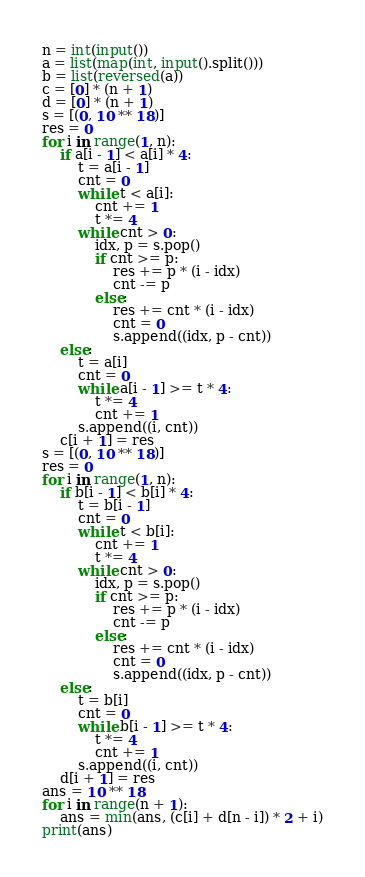Convert code to text. <code><loc_0><loc_0><loc_500><loc_500><_Python_>n = int(input())
a = list(map(int, input().split()))
b = list(reversed(a))
c = [0] * (n + 1)
d = [0] * (n + 1)
s = [(0, 10 ** 18)]
res = 0
for i in range(1, n):
    if a[i - 1] < a[i] * 4:
        t = a[i - 1]
        cnt = 0
        while t < a[i]:
            cnt += 1
            t *= 4
        while cnt > 0:
            idx, p = s.pop()
            if cnt >= p:
                res += p * (i - idx)
                cnt -= p
            else:
                res += cnt * (i - idx)
                cnt = 0
                s.append((idx, p - cnt))
    else:
        t = a[i]
        cnt = 0
        while a[i - 1] >= t * 4:
            t *= 4
            cnt += 1
        s.append((i, cnt))
    c[i + 1] = res
s = [(0, 10 ** 18)]
res = 0
for i in range(1, n):
    if b[i - 1] < b[i] * 4:
        t = b[i - 1]
        cnt = 0
        while t < b[i]:
            cnt += 1
            t *= 4
        while cnt > 0:
            idx, p = s.pop()
            if cnt >= p:
                res += p * (i - idx)
                cnt -= p
            else:
                res += cnt * (i - idx)
                cnt = 0
                s.append((idx, p - cnt))
    else:
        t = b[i]
        cnt = 0
        while b[i - 1] >= t * 4:
            t *= 4
            cnt += 1
        s.append((i, cnt))
    d[i + 1] = res
ans = 10 ** 18
for i in range(n + 1):
    ans = min(ans, (c[i] + d[n - i]) * 2 + i)
print(ans)
</code> 